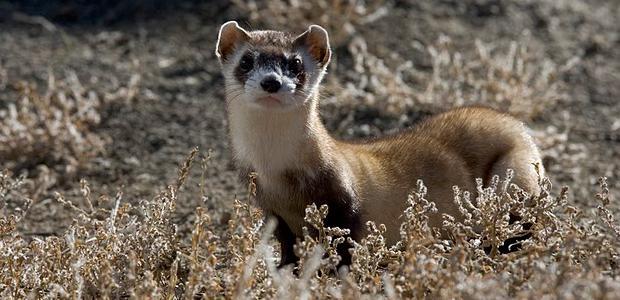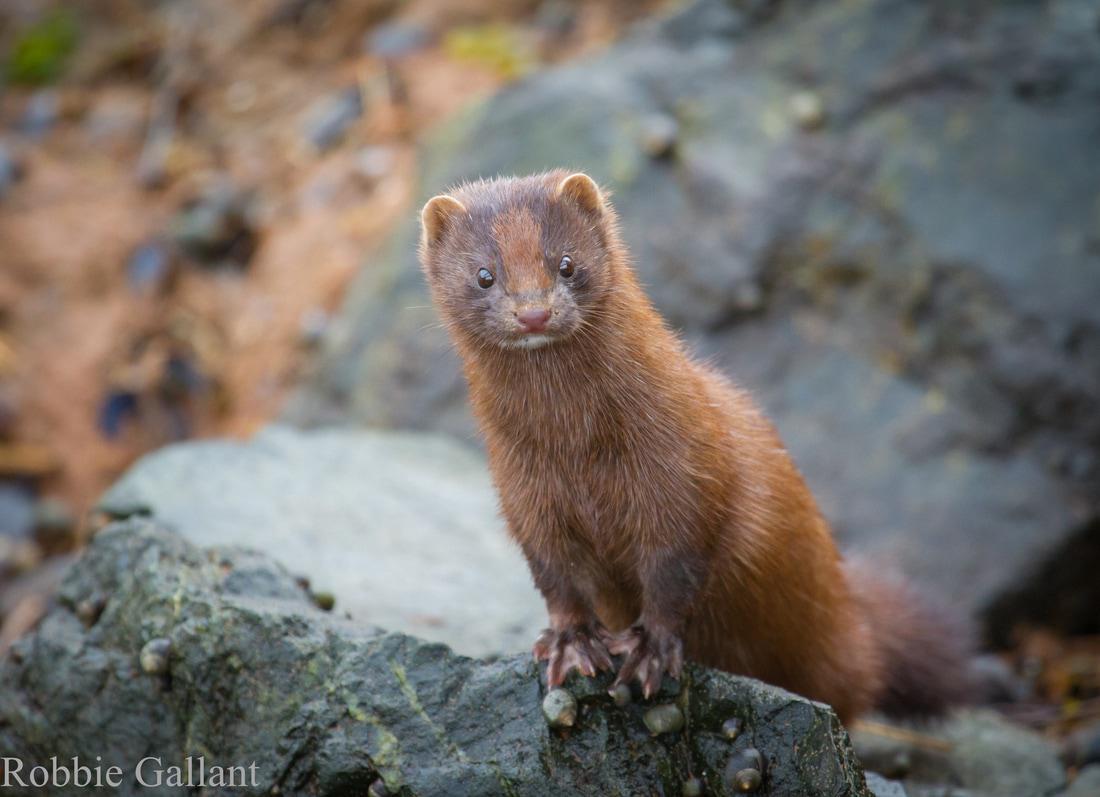The first image is the image on the left, the second image is the image on the right. Given the left and right images, does the statement "There are more animals in the image on the right." hold true? Answer yes or no. No. The first image is the image on the left, the second image is the image on the right. Given the left and right images, does the statement "The right image contains at least two ferrets." hold true? Answer yes or no. No. 